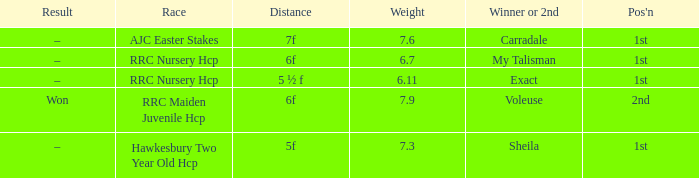Could you parse the entire table? {'header': ['Result', 'Race', 'Distance', 'Weight', 'Winner or 2nd', "Pos'n"], 'rows': [['–', 'AJC Easter Stakes', '7f', '7.6', 'Carradale', '1st'], ['–', 'RRC Nursery Hcp', '6f', '6.7', 'My Talisman', '1st'], ['–', 'RRC Nursery Hcp', '5 ½ f', '6.11', 'Exact', '1st'], ['Won', 'RRC Maiden Juvenile Hcp', '6f', '7.9', 'Voleuse', '2nd'], ['–', 'Hawkesbury Two Year Old Hcp', '5f', '7.3', 'Sheila', '1st']]} What was the race when the winner of 2nd was Voleuse? RRC Maiden Juvenile Hcp. 